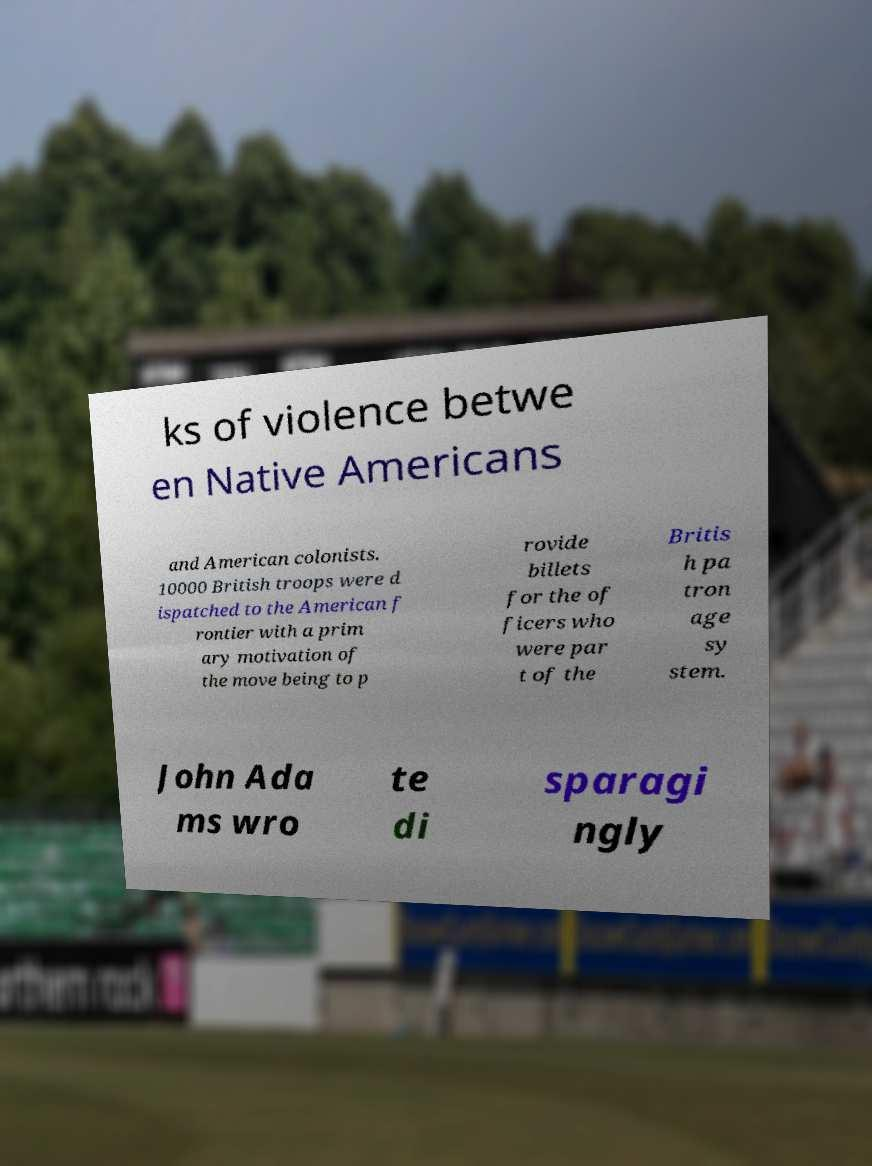Could you extract and type out the text from this image? ks of violence betwe en Native Americans and American colonists. 10000 British troops were d ispatched to the American f rontier with a prim ary motivation of the move being to p rovide billets for the of ficers who were par t of the Britis h pa tron age sy stem. John Ada ms wro te di sparagi ngly 